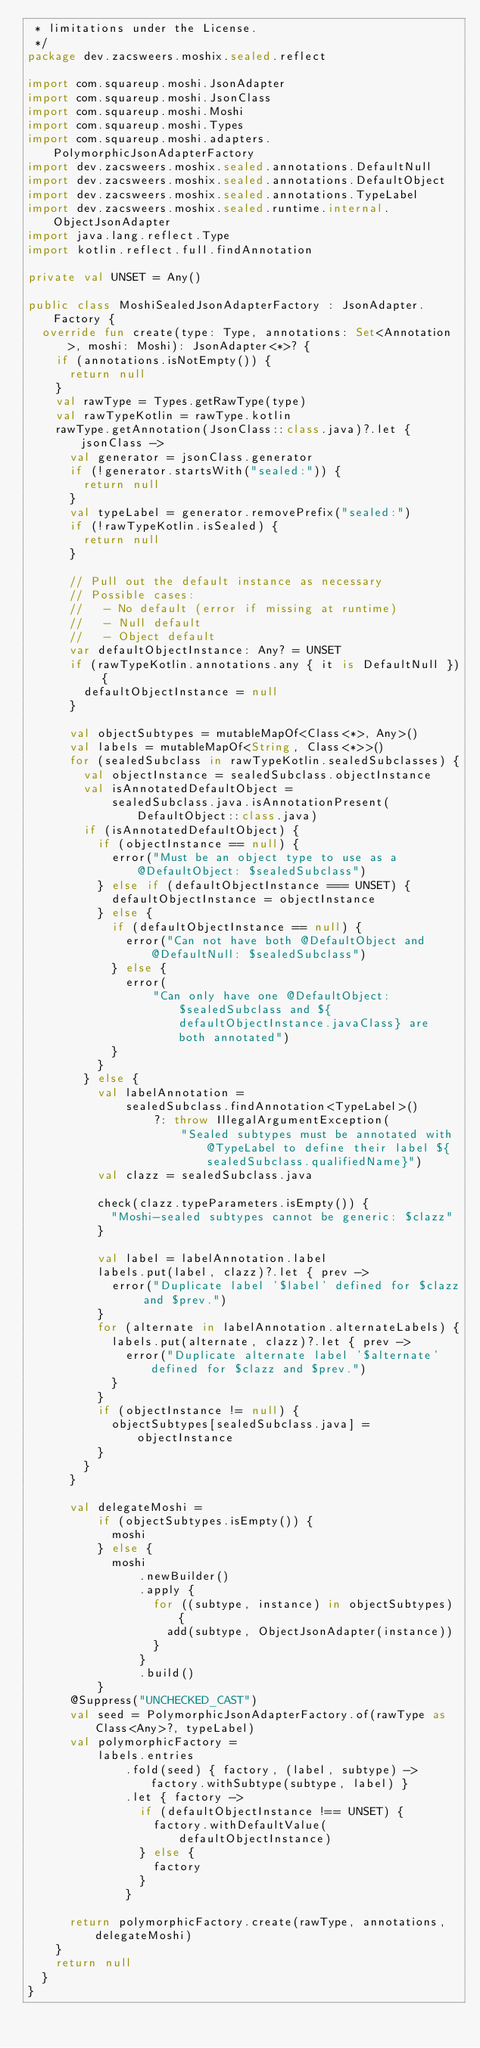Convert code to text. <code><loc_0><loc_0><loc_500><loc_500><_Kotlin_> * limitations under the License.
 */
package dev.zacsweers.moshix.sealed.reflect

import com.squareup.moshi.JsonAdapter
import com.squareup.moshi.JsonClass
import com.squareup.moshi.Moshi
import com.squareup.moshi.Types
import com.squareup.moshi.adapters.PolymorphicJsonAdapterFactory
import dev.zacsweers.moshix.sealed.annotations.DefaultNull
import dev.zacsweers.moshix.sealed.annotations.DefaultObject
import dev.zacsweers.moshix.sealed.annotations.TypeLabel
import dev.zacsweers.moshix.sealed.runtime.internal.ObjectJsonAdapter
import java.lang.reflect.Type
import kotlin.reflect.full.findAnnotation

private val UNSET = Any()

public class MoshiSealedJsonAdapterFactory : JsonAdapter.Factory {
  override fun create(type: Type, annotations: Set<Annotation>, moshi: Moshi): JsonAdapter<*>? {
    if (annotations.isNotEmpty()) {
      return null
    }
    val rawType = Types.getRawType(type)
    val rawTypeKotlin = rawType.kotlin
    rawType.getAnnotation(JsonClass::class.java)?.let { jsonClass ->
      val generator = jsonClass.generator
      if (!generator.startsWith("sealed:")) {
        return null
      }
      val typeLabel = generator.removePrefix("sealed:")
      if (!rawTypeKotlin.isSealed) {
        return null
      }

      // Pull out the default instance as necessary
      // Possible cases:
      //   - No default (error if missing at runtime)
      //   - Null default
      //   - Object default
      var defaultObjectInstance: Any? = UNSET
      if (rawTypeKotlin.annotations.any { it is DefaultNull }) {
        defaultObjectInstance = null
      }

      val objectSubtypes = mutableMapOf<Class<*>, Any>()
      val labels = mutableMapOf<String, Class<*>>()
      for (sealedSubclass in rawTypeKotlin.sealedSubclasses) {
        val objectInstance = sealedSubclass.objectInstance
        val isAnnotatedDefaultObject =
            sealedSubclass.java.isAnnotationPresent(DefaultObject::class.java)
        if (isAnnotatedDefaultObject) {
          if (objectInstance == null) {
            error("Must be an object type to use as a @DefaultObject: $sealedSubclass")
          } else if (defaultObjectInstance === UNSET) {
            defaultObjectInstance = objectInstance
          } else {
            if (defaultObjectInstance == null) {
              error("Can not have both @DefaultObject and @DefaultNull: $sealedSubclass")
            } else {
              error(
                  "Can only have one @DefaultObject: $sealedSubclass and ${defaultObjectInstance.javaClass} are both annotated")
            }
          }
        } else {
          val labelAnnotation =
              sealedSubclass.findAnnotation<TypeLabel>()
                  ?: throw IllegalArgumentException(
                      "Sealed subtypes must be annotated with @TypeLabel to define their label ${sealedSubclass.qualifiedName}")
          val clazz = sealedSubclass.java

          check(clazz.typeParameters.isEmpty()) {
            "Moshi-sealed subtypes cannot be generic: $clazz"
          }

          val label = labelAnnotation.label
          labels.put(label, clazz)?.let { prev ->
            error("Duplicate label '$label' defined for $clazz and $prev.")
          }
          for (alternate in labelAnnotation.alternateLabels) {
            labels.put(alternate, clazz)?.let { prev ->
              error("Duplicate alternate label '$alternate' defined for $clazz and $prev.")
            }
          }
          if (objectInstance != null) {
            objectSubtypes[sealedSubclass.java] = objectInstance
          }
        }
      }

      val delegateMoshi =
          if (objectSubtypes.isEmpty()) {
            moshi
          } else {
            moshi
                .newBuilder()
                .apply {
                  for ((subtype, instance) in objectSubtypes) {
                    add(subtype, ObjectJsonAdapter(instance))
                  }
                }
                .build()
          }
      @Suppress("UNCHECKED_CAST")
      val seed = PolymorphicJsonAdapterFactory.of(rawType as Class<Any>?, typeLabel)
      val polymorphicFactory =
          labels.entries
              .fold(seed) { factory, (label, subtype) -> factory.withSubtype(subtype, label) }
              .let { factory ->
                if (defaultObjectInstance !== UNSET) {
                  factory.withDefaultValue(defaultObjectInstance)
                } else {
                  factory
                }
              }

      return polymorphicFactory.create(rawType, annotations, delegateMoshi)
    }
    return null
  }
}
</code> 